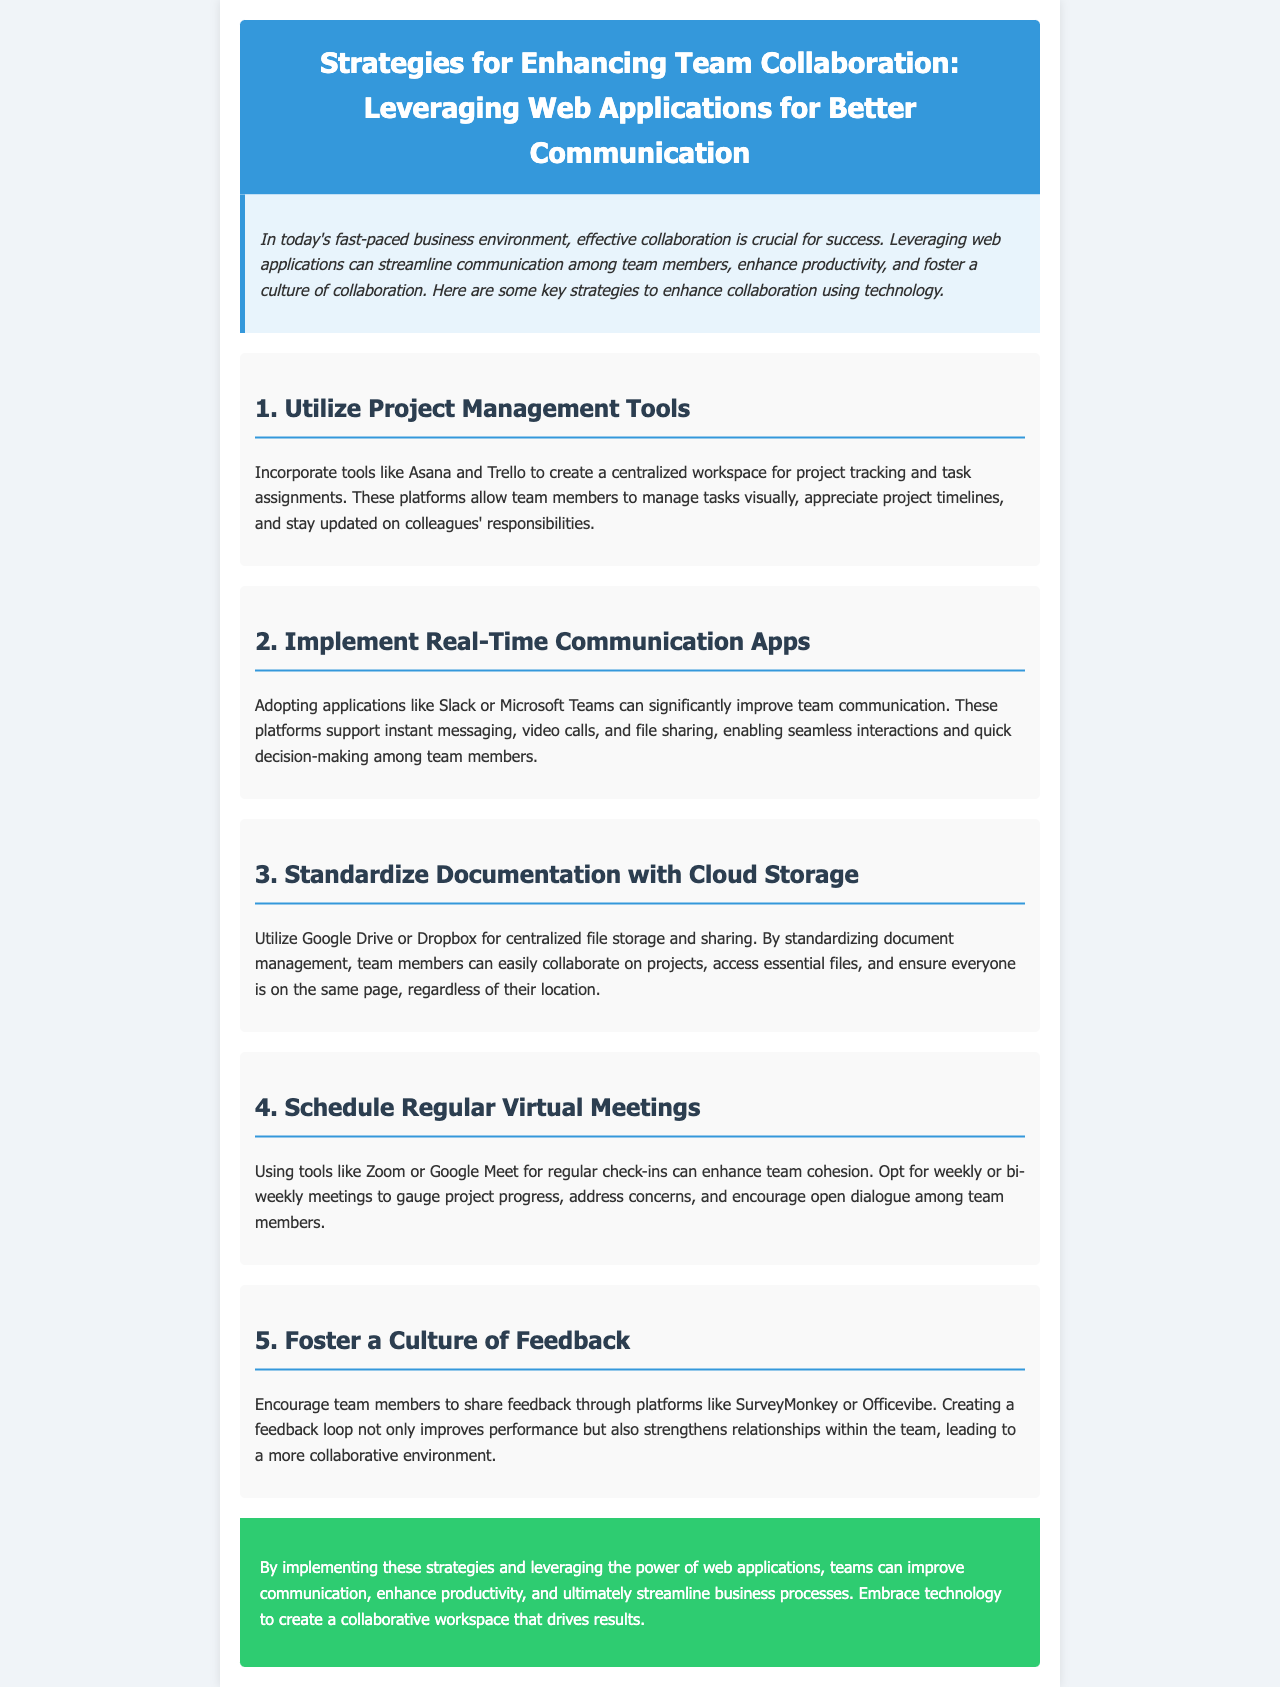What is the title of the newsletter? The title is presented prominently at the top of the document, providing the main focus of the content.
Answer: Strategies for Enhancing Team Collaboration: Leveraging Web Applications for Better Communication What is the first strategy mentioned for enhancing team collaboration? The first strategy outlined in the sections details a specific method to improve collaboration by utilizing tools.
Answer: Utilize Project Management Tools Which platforms are suggested for real-time communication? The document mentions specific applications that enhance communication among team members.
Answer: Slack or Microsoft Teams What type of technology does the document emphasize for standardizing documentation? The section discusses a particular technology category beneficial for document management and collaboration.
Answer: Cloud Storage How often should virtual meetings be scheduled according to the newsletter? This detail relates to the recommended frequency for maintaining team cohesion via meetings.
Answer: Weekly or bi-weekly What is the purpose of fostering a culture of feedback? The document explains the benefits of receiving feedback in relation to team dynamics and performance.
Answer: Improves performance How can feedback be shared according to the document? This question relates to the specific platforms mentioned for gathering team input.
Answer: SurveyMonkey or Officevibe What is the expected outcome of implementing the strategies discussed? The conclusion summarizes the overall benefits of the strategies in improving processes and collaboration.
Answer: Streamline business processes 